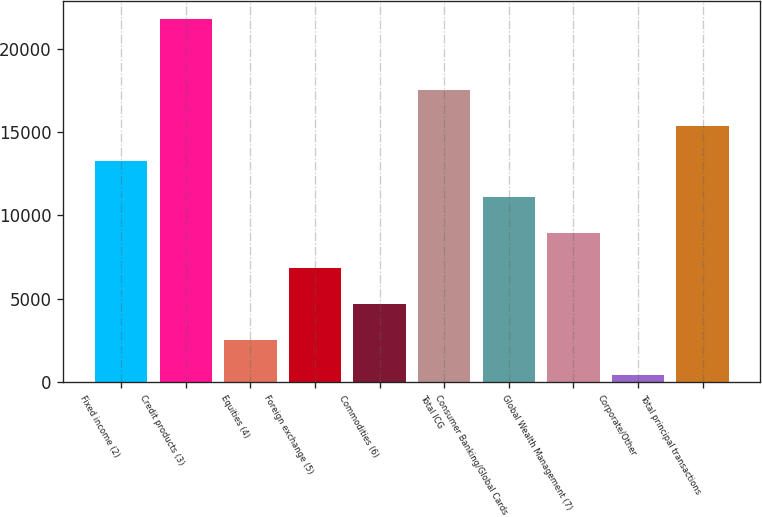<chart> <loc_0><loc_0><loc_500><loc_500><bar_chart><fcel>Fixed income (2)<fcel>Credit products (3)<fcel>Equities (4)<fcel>Foreign exchange (5)<fcel>Commodities (6)<fcel>Total ICG<fcel>Consumer Banking/Global Cards<fcel>Global Wealth Management (7)<fcel>Corporate/Other<fcel>Total principal transactions<nl><fcel>13241.8<fcel>21805<fcel>2537.8<fcel>6819.4<fcel>4678.6<fcel>17523.4<fcel>11101<fcel>8960.2<fcel>397<fcel>15382.6<nl></chart> 